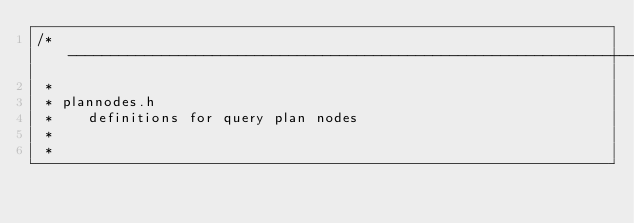Convert code to text. <code><loc_0><loc_0><loc_500><loc_500><_C_>/*-------------------------------------------------------------------------
 *
 * plannodes.h
 *	  definitions for query plan nodes
 *
 *</code> 